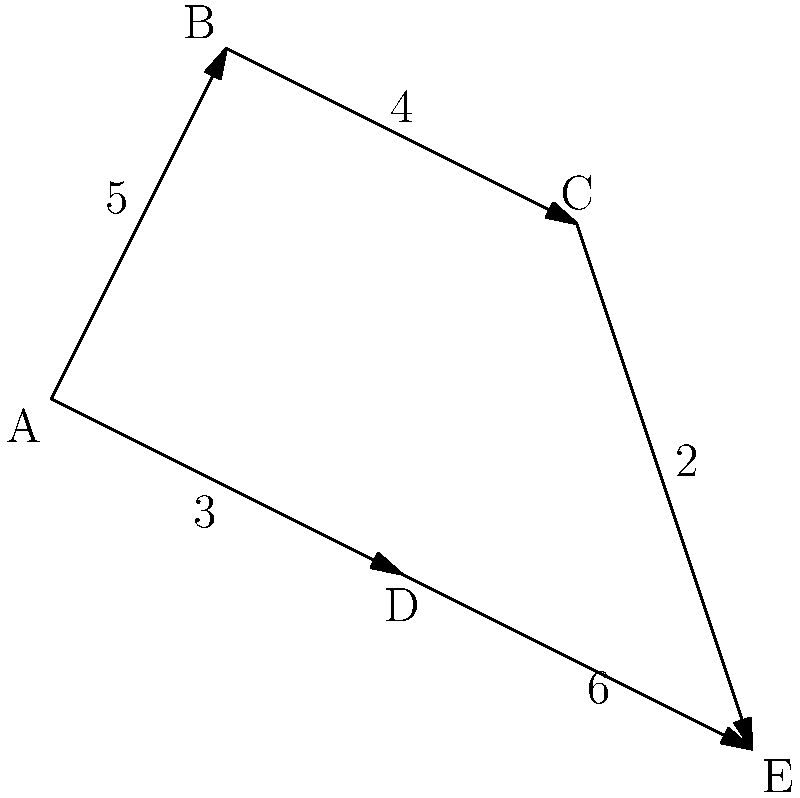As a military engineer tasked with optimizing the water supply system for a new base, you're given a network diagram representing potential pipeline routes. Each node represents a strategic location, and the edges represent possible pipeline connections with their associated costs (in millions of dollars). What is the minimum cost to connect all locations in the most efficient manner? To find the minimum cost to connect all locations, we need to find the Minimum Spanning Tree (MST) of the given network. We can use Kruskal's algorithm to solve this problem:

1. Sort all edges by weight (cost) in ascending order:
   (C,E): 2
   (A,D): 3
   (B,C): 4
   (A,B): 5
   (D,E): 6

2. Start with an empty set of edges and add edges one by one, ensuring no cycles are formed:
   - Add (C,E): 2
   - Add (A,D): 3
   - Add (B,C): 4
   - Add (A,B): 5

3. We now have a Minimum Spanning Tree connecting all nodes:
   A -- B -- C -- E
   |
   D

4. Sum up the costs of the edges in the MST:
   2 + 3 + 4 + 5 = 14

Therefore, the minimum cost to connect all locations is $14 million.
Answer: $14 million 